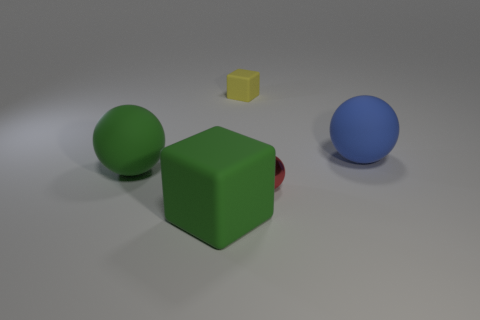Are there any balls left of the green ball?
Your answer should be very brief. No. What number of things are either tiny red balls or big matte balls that are to the left of the large rubber block?
Give a very brief answer. 2. Are there any yellow rubber blocks that are right of the big rubber object right of the small cube?
Your response must be concise. No. There is a yellow rubber thing that is behind the matte block in front of the tiny red metallic thing in front of the green matte ball; what is its shape?
Provide a succinct answer. Cube. The rubber object that is right of the large green cube and in front of the tiny yellow thing is what color?
Your response must be concise. Blue. What shape is the large rubber object right of the small shiny object?
Make the answer very short. Sphere. What is the shape of the blue thing that is made of the same material as the tiny block?
Your answer should be compact. Sphere. What number of rubber objects are yellow cubes or purple things?
Your answer should be very brief. 1. What number of yellow blocks are in front of the green matte object that is on the right side of the big sphere left of the red object?
Ensure brevity in your answer.  0. There is a rubber block that is in front of the tiny red sphere; does it have the same size as the yellow matte cube that is behind the blue rubber thing?
Provide a succinct answer. No. 